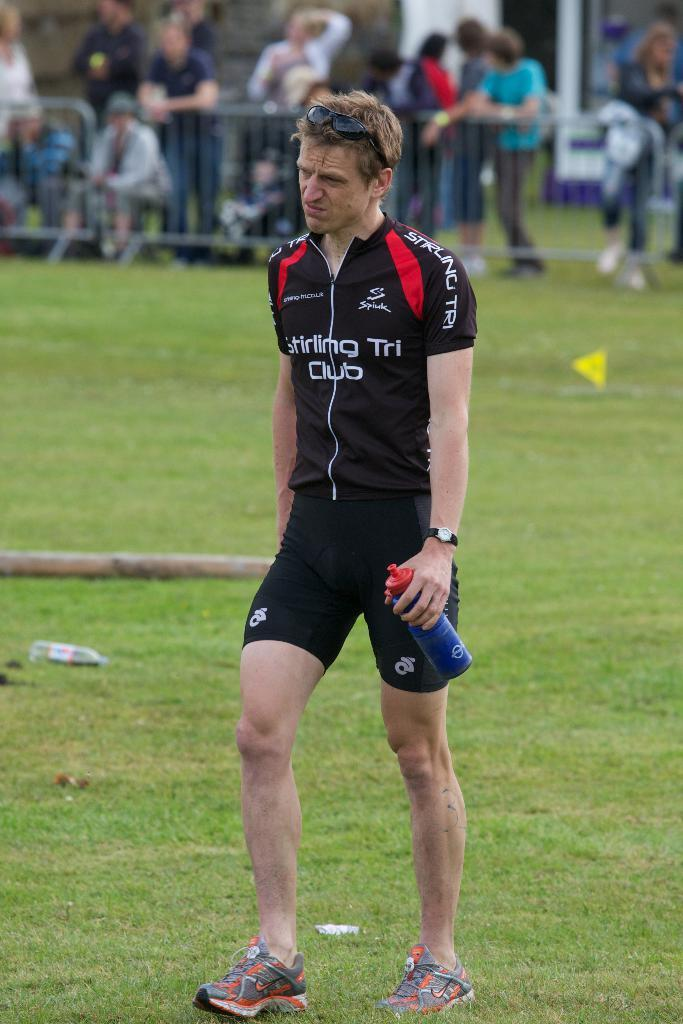<image>
Present a compact description of the photo's key features. A man wearing a Stirling Tri Club cycling jersey walks across a grass field with a water bottle in one hand. 